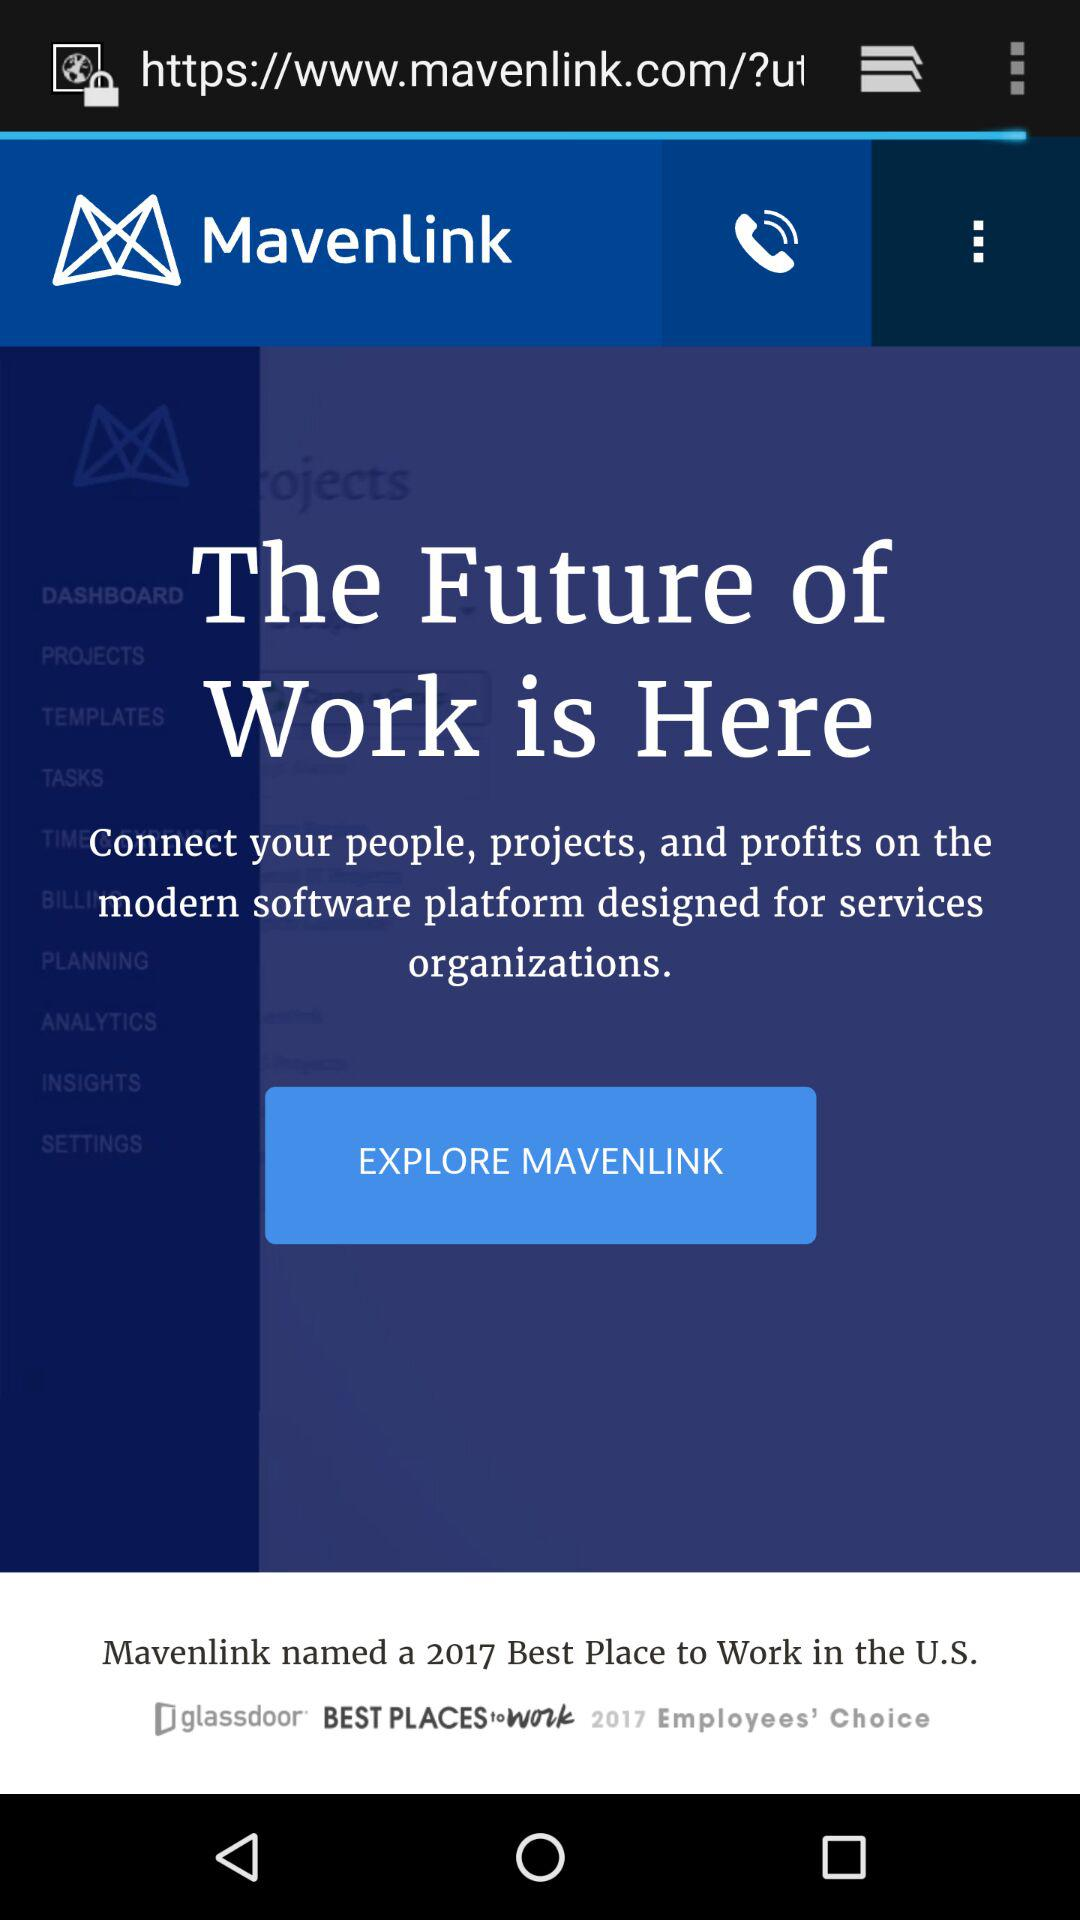Which organization is named the best place to work in the U.S.? The organization "Mavenlink" is named the best place to work in the U.S. 